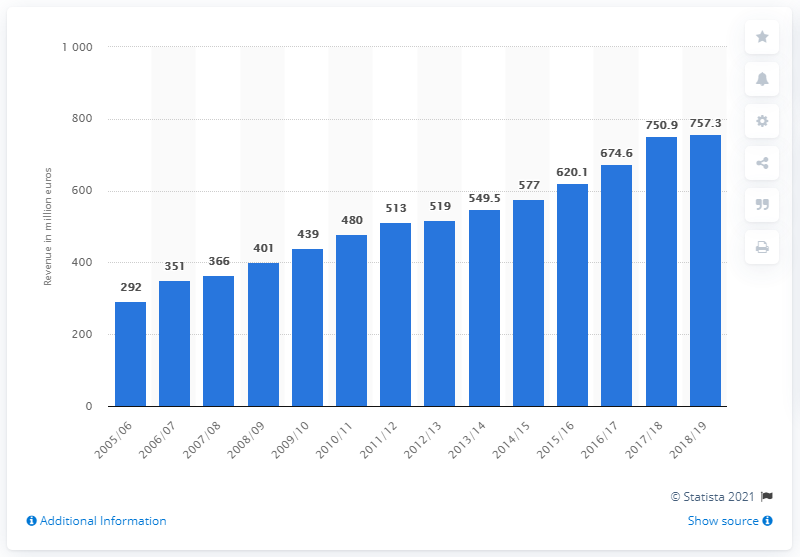Highlight a few significant elements in this photo. In the 2018/2019 season, Real Madrid generated a total revenue of 757.3 million Euros. 